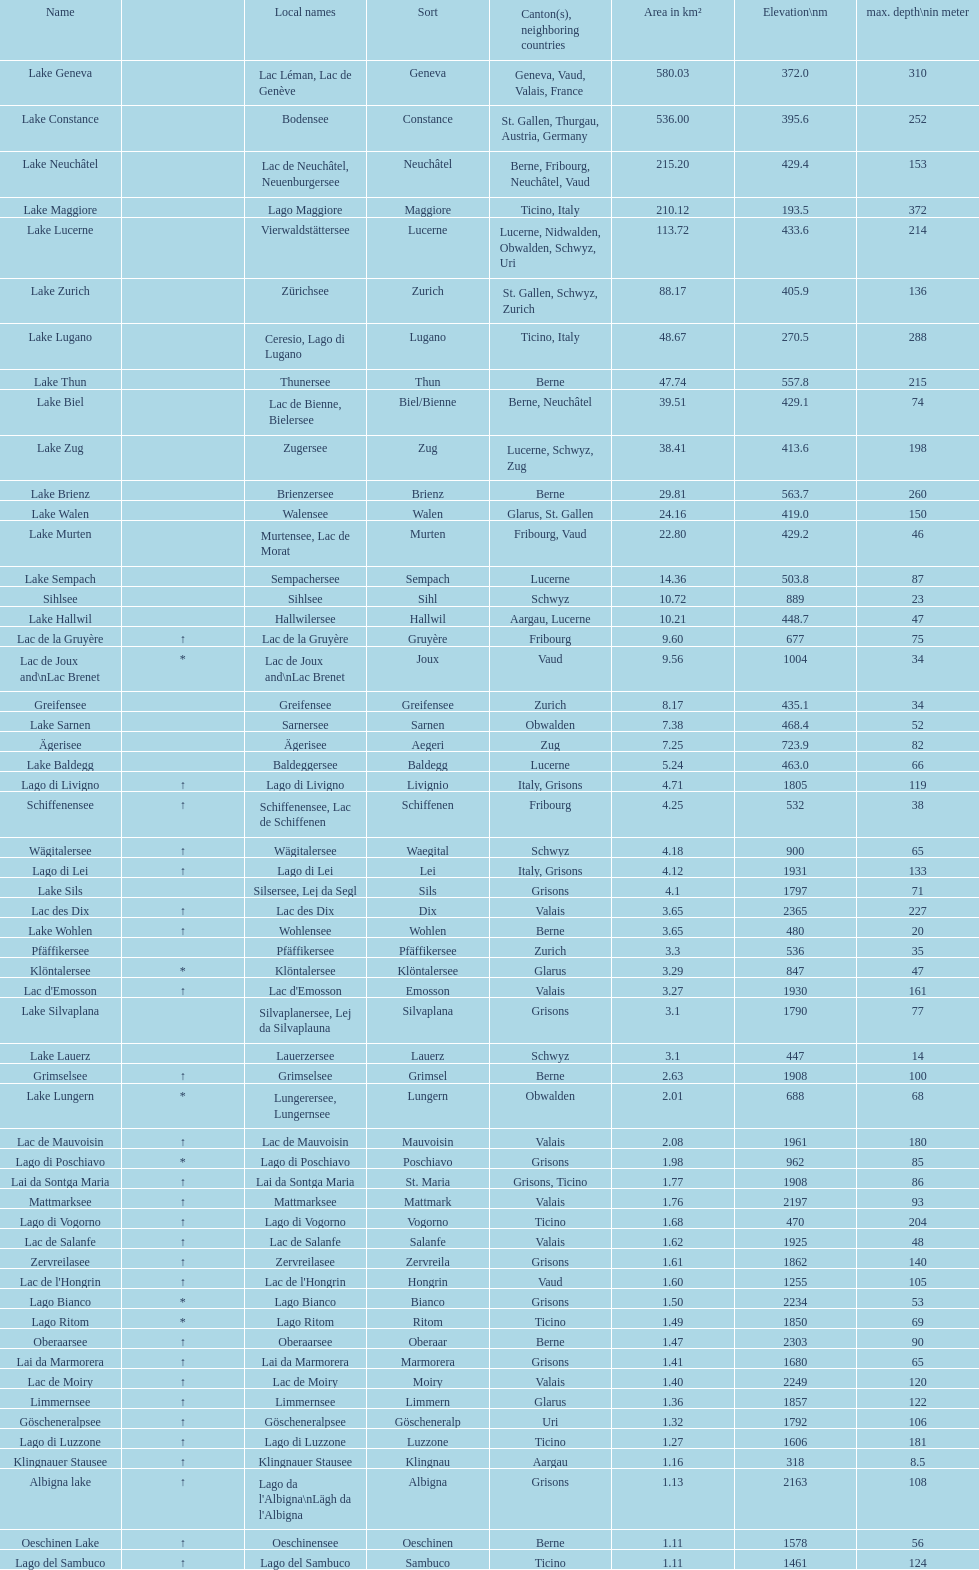What lake holds the following highest elevation after lac des dix? Oberaarsee. 